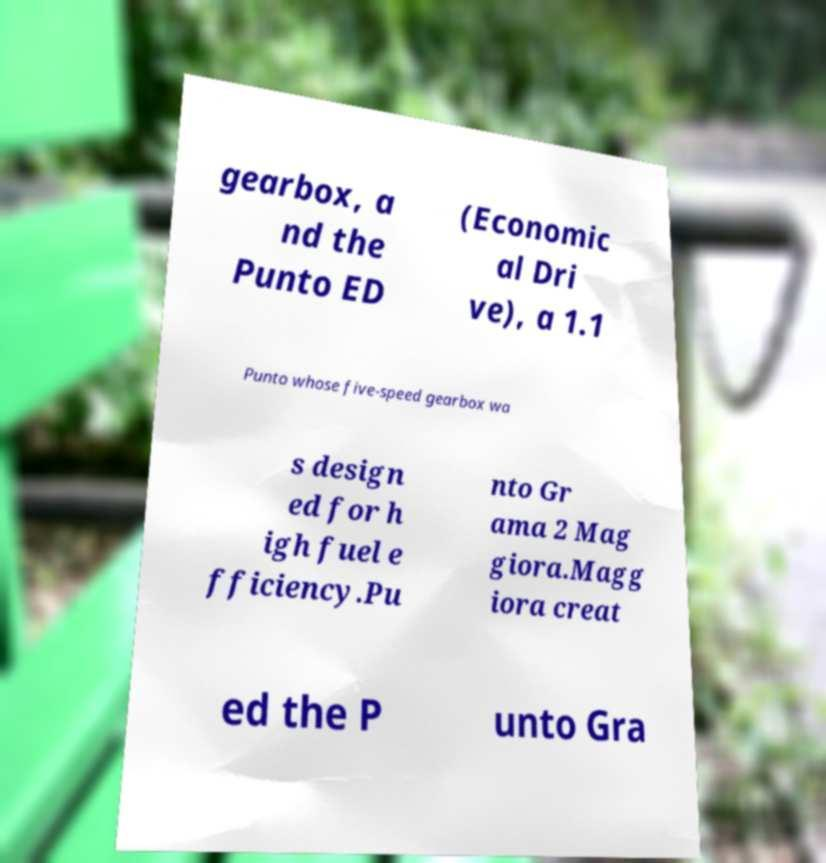Can you read and provide the text displayed in the image?This photo seems to have some interesting text. Can you extract and type it out for me? gearbox, a nd the Punto ED (Economic al Dri ve), a 1.1 Punto whose five-speed gearbox wa s design ed for h igh fuel e fficiency.Pu nto Gr ama 2 Mag giora.Magg iora creat ed the P unto Gra 